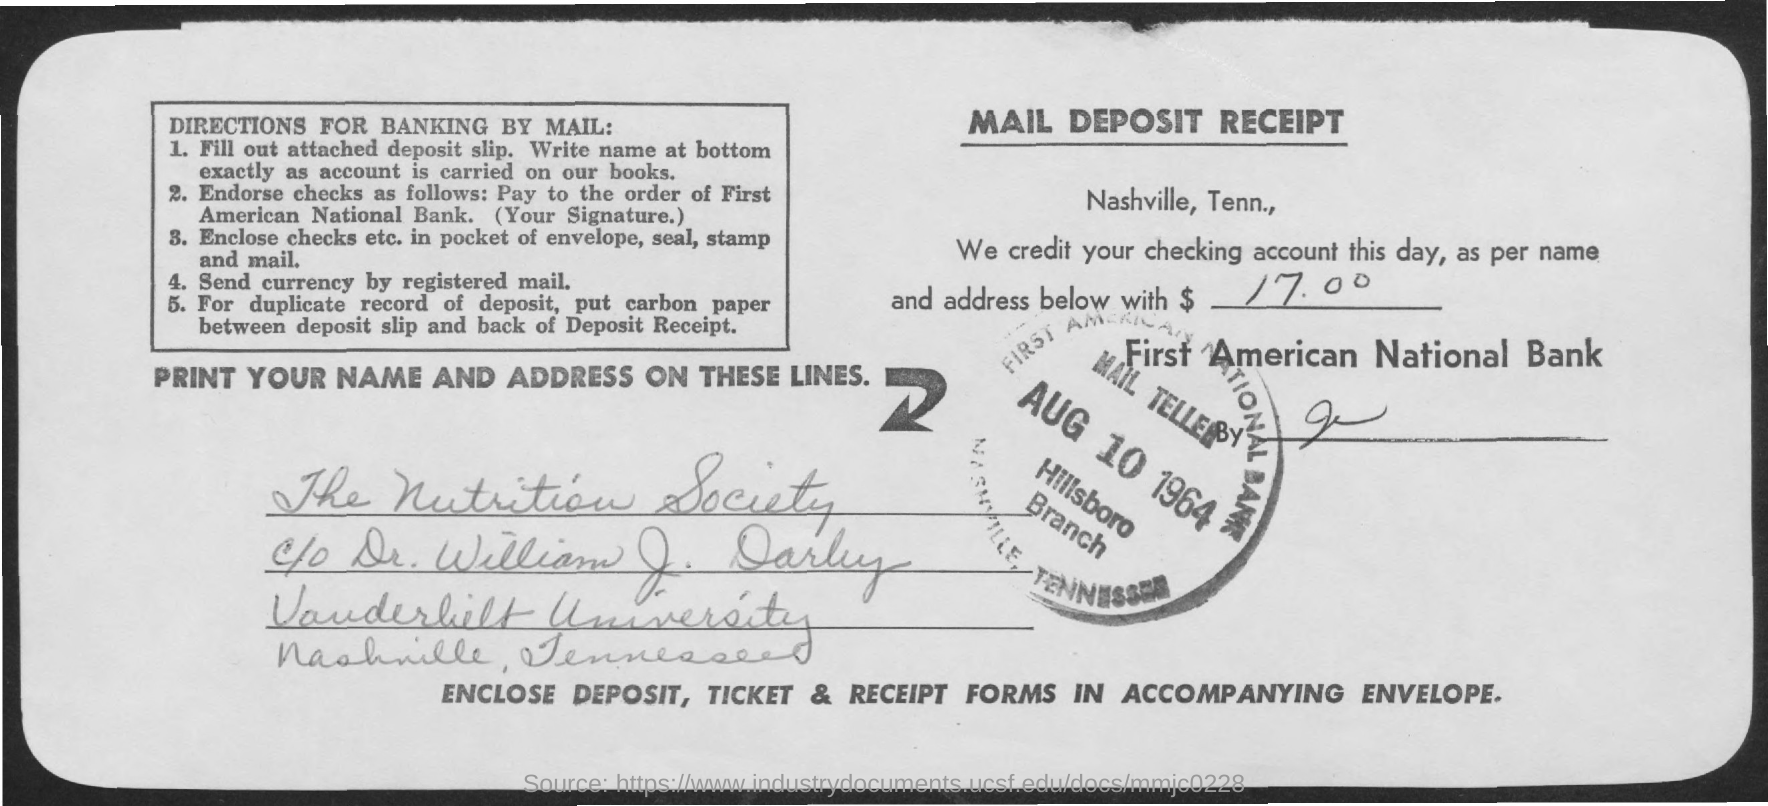Draw attention to some important aspects in this diagram. The receipt provided is a mail deposit receipt. The amount credited, as mentioned in the email deposit receipt, is $17.00. 